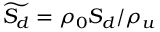<formula> <loc_0><loc_0><loc_500><loc_500>\widetilde { S _ { d } } = \rho _ { 0 } S _ { d } / \rho _ { u }</formula> 